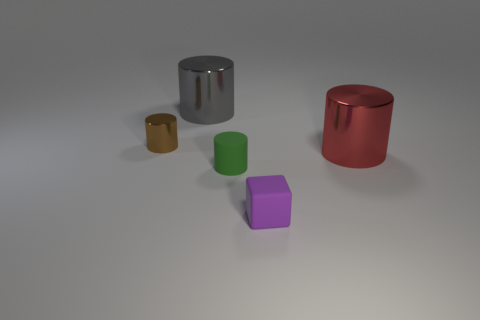Add 2 small gray objects. How many objects exist? 7 Subtract all gray cylinders. How many cylinders are left? 3 Subtract all gray cylinders. How many cylinders are left? 3 Subtract all cylinders. How many objects are left? 1 Subtract 4 cylinders. How many cylinders are left? 0 Add 2 small purple blocks. How many small purple blocks are left? 3 Add 4 small green matte cylinders. How many small green matte cylinders exist? 5 Subtract 0 brown blocks. How many objects are left? 5 Subtract all brown cylinders. Subtract all cyan balls. How many cylinders are left? 3 Subtract all purple cylinders. How many blue cubes are left? 0 